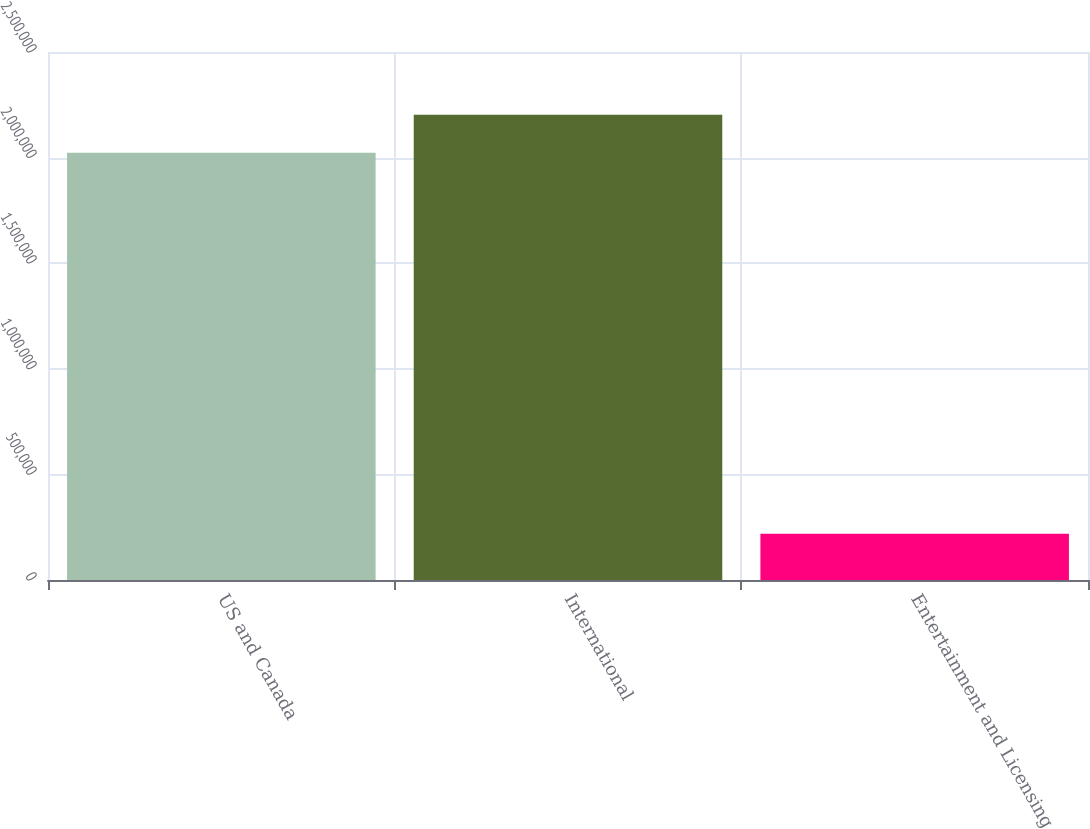Convert chart to OTSL. <chart><loc_0><loc_0><loc_500><loc_500><bar_chart><fcel>US and Canada<fcel>International<fcel>Entertainment and Licensing<nl><fcel>2.02244e+06<fcel>2.2028e+06<fcel>219465<nl></chart> 